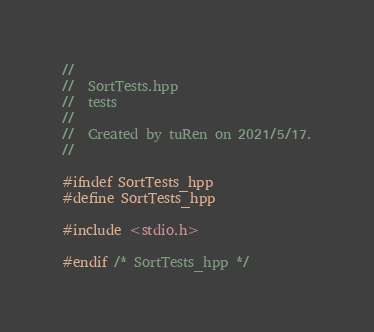Convert code to text. <code><loc_0><loc_0><loc_500><loc_500><_C++_>//
//  SortTests.hpp
//  tests
//
//  Created by tuRen on 2021/5/17.
//

#ifndef SortTests_hpp
#define SortTests_hpp

#include <stdio.h>

#endif /* SortTests_hpp */
</code> 